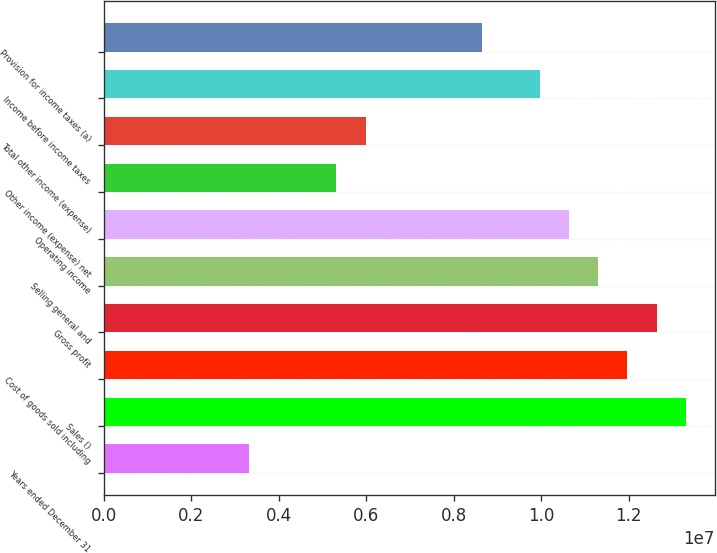<chart> <loc_0><loc_0><loc_500><loc_500><bar_chart><fcel>Years ended December 31<fcel>Sales ()<fcel>Cost of goods sold including<fcel>Gross profit<fcel>Selling general and<fcel>Operating income<fcel>Other income (expense) net<fcel>Total other income (expense)<fcel>Income before income taxes<fcel>Provision for income taxes (a)<nl><fcel>3.32462e+06<fcel>1.32985e+07<fcel>1.19686e+07<fcel>1.26335e+07<fcel>1.13037e+07<fcel>1.06388e+07<fcel>5.31939e+06<fcel>5.98431e+06<fcel>9.97385e+06<fcel>8.64401e+06<nl></chart> 